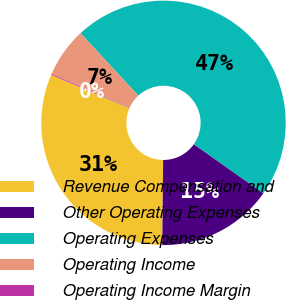Convert chart. <chart><loc_0><loc_0><loc_500><loc_500><pie_chart><fcel>Revenue Compensation and<fcel>Other Operating Expenses<fcel>Operating Expenses<fcel>Operating Income<fcel>Operating Income Margin<nl><fcel>31.27%<fcel>15.39%<fcel>46.66%<fcel>6.56%<fcel>0.12%<nl></chart> 